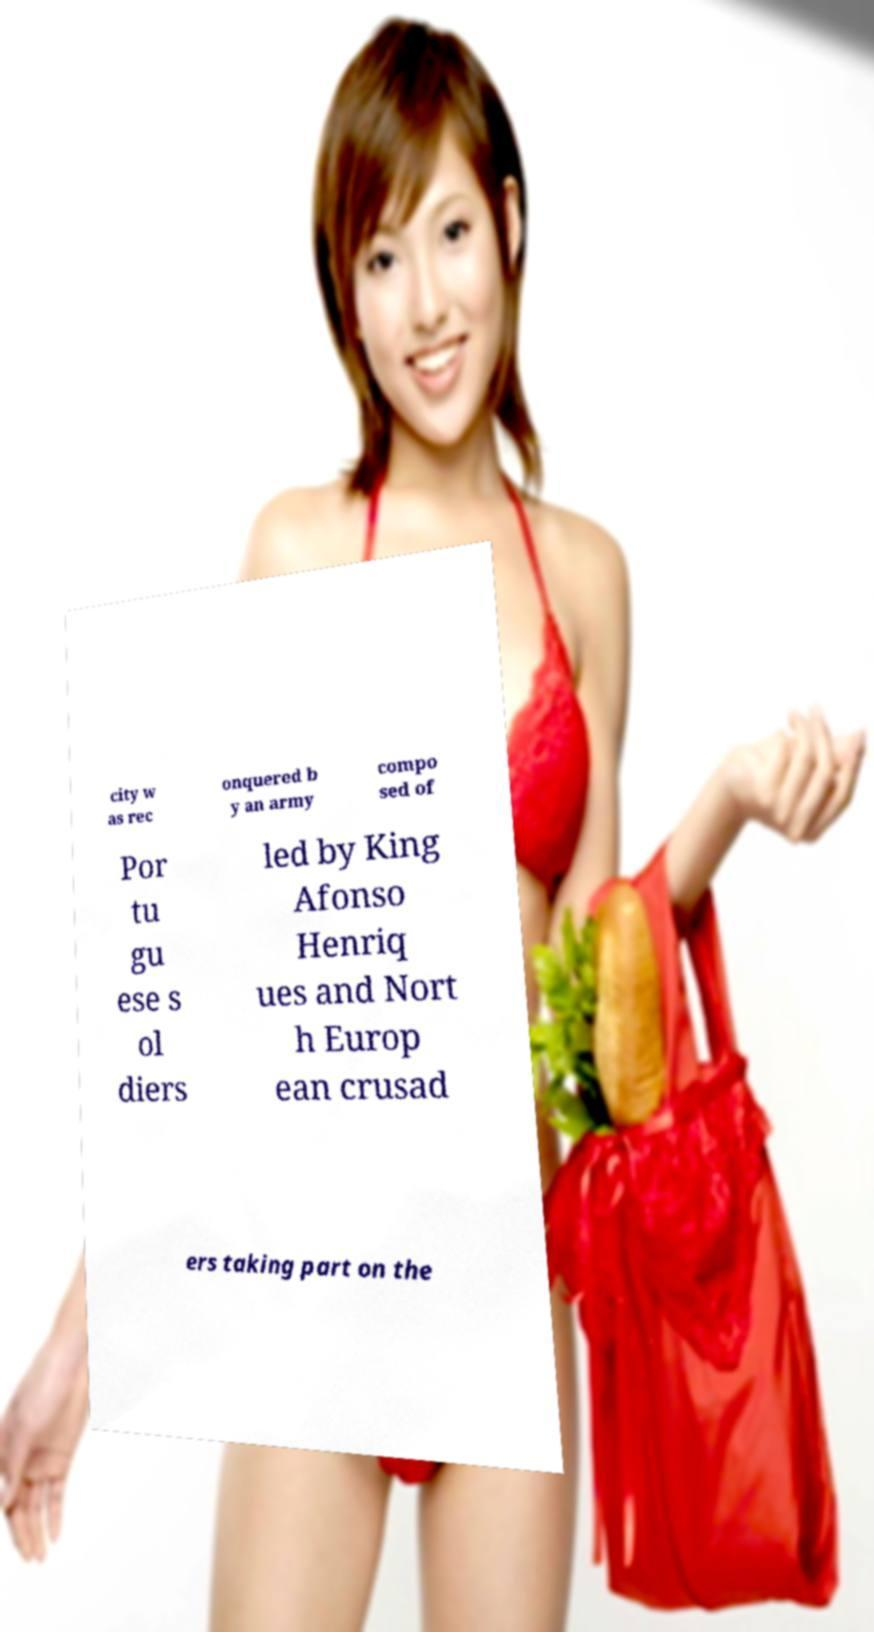Can you read and provide the text displayed in the image?This photo seems to have some interesting text. Can you extract and type it out for me? city w as rec onquered b y an army compo sed of Por tu gu ese s ol diers led by King Afonso Henriq ues and Nort h Europ ean crusad ers taking part on the 